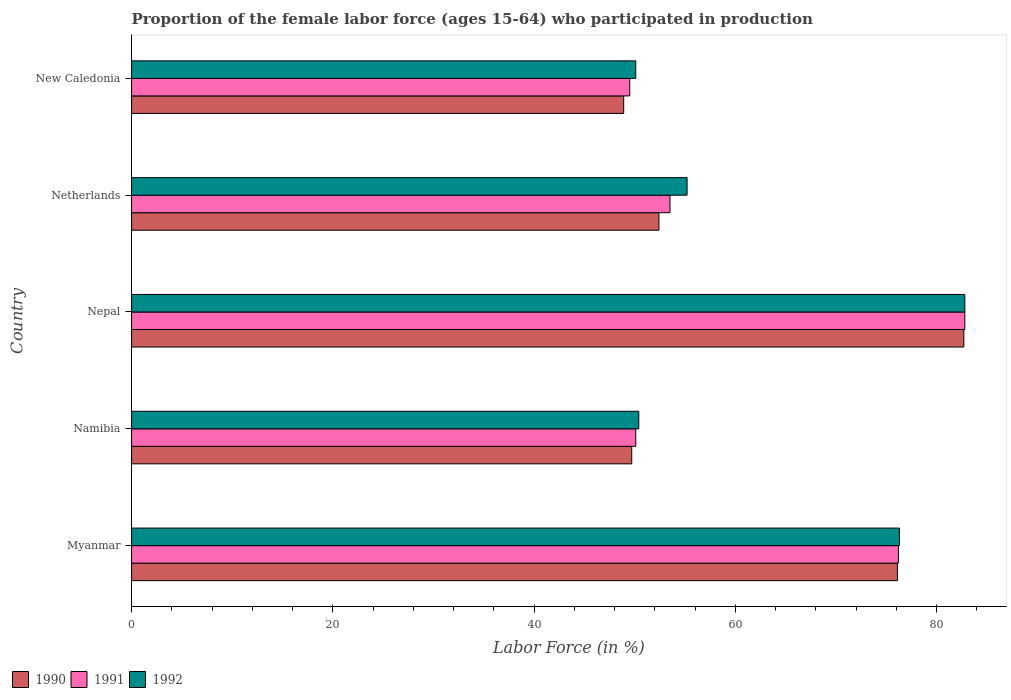Are the number of bars on each tick of the Y-axis equal?
Make the answer very short. Yes. How many bars are there on the 2nd tick from the top?
Your answer should be compact. 3. How many bars are there on the 2nd tick from the bottom?
Keep it short and to the point. 3. In how many cases, is the number of bars for a given country not equal to the number of legend labels?
Provide a short and direct response. 0. What is the proportion of the female labor force who participated in production in 1991 in Myanmar?
Ensure brevity in your answer.  76.2. Across all countries, what is the maximum proportion of the female labor force who participated in production in 1990?
Offer a very short reply. 82.7. Across all countries, what is the minimum proportion of the female labor force who participated in production in 1991?
Your answer should be very brief. 49.5. In which country was the proportion of the female labor force who participated in production in 1992 maximum?
Offer a terse response. Nepal. In which country was the proportion of the female labor force who participated in production in 1991 minimum?
Keep it short and to the point. New Caledonia. What is the total proportion of the female labor force who participated in production in 1992 in the graph?
Provide a succinct answer. 314.8. What is the difference between the proportion of the female labor force who participated in production in 1990 in Nepal and that in New Caledonia?
Your response must be concise. 33.8. What is the difference between the proportion of the female labor force who participated in production in 1990 in Netherlands and the proportion of the female labor force who participated in production in 1991 in Myanmar?
Your answer should be compact. -23.8. What is the average proportion of the female labor force who participated in production in 1990 per country?
Your answer should be very brief. 61.96. What is the difference between the proportion of the female labor force who participated in production in 1990 and proportion of the female labor force who participated in production in 1992 in New Caledonia?
Your answer should be very brief. -1.2. In how many countries, is the proportion of the female labor force who participated in production in 1990 greater than 24 %?
Offer a terse response. 5. What is the ratio of the proportion of the female labor force who participated in production in 1991 in Netherlands to that in New Caledonia?
Keep it short and to the point. 1.08. Is the difference between the proportion of the female labor force who participated in production in 1990 in Netherlands and New Caledonia greater than the difference between the proportion of the female labor force who participated in production in 1992 in Netherlands and New Caledonia?
Your response must be concise. No. What is the difference between the highest and the second highest proportion of the female labor force who participated in production in 1992?
Offer a very short reply. 6.5. What is the difference between the highest and the lowest proportion of the female labor force who participated in production in 1992?
Make the answer very short. 32.7. What does the 1st bar from the top in New Caledonia represents?
Keep it short and to the point. 1992. What does the 3rd bar from the bottom in Nepal represents?
Offer a terse response. 1992. Is it the case that in every country, the sum of the proportion of the female labor force who participated in production in 1992 and proportion of the female labor force who participated in production in 1990 is greater than the proportion of the female labor force who participated in production in 1991?
Your answer should be very brief. Yes. How many bars are there?
Provide a succinct answer. 15. How many countries are there in the graph?
Offer a very short reply. 5. What is the difference between two consecutive major ticks on the X-axis?
Give a very brief answer. 20. Does the graph contain any zero values?
Give a very brief answer. No. Does the graph contain grids?
Provide a short and direct response. No. How many legend labels are there?
Provide a succinct answer. 3. What is the title of the graph?
Provide a short and direct response. Proportion of the female labor force (ages 15-64) who participated in production. Does "2011" appear as one of the legend labels in the graph?
Offer a terse response. No. What is the label or title of the X-axis?
Your answer should be very brief. Labor Force (in %). What is the Labor Force (in %) of 1990 in Myanmar?
Make the answer very short. 76.1. What is the Labor Force (in %) of 1991 in Myanmar?
Make the answer very short. 76.2. What is the Labor Force (in %) of 1992 in Myanmar?
Offer a terse response. 76.3. What is the Labor Force (in %) in 1990 in Namibia?
Keep it short and to the point. 49.7. What is the Labor Force (in %) of 1991 in Namibia?
Offer a very short reply. 50.1. What is the Labor Force (in %) of 1992 in Namibia?
Keep it short and to the point. 50.4. What is the Labor Force (in %) of 1990 in Nepal?
Make the answer very short. 82.7. What is the Labor Force (in %) in 1991 in Nepal?
Offer a very short reply. 82.8. What is the Labor Force (in %) in 1992 in Nepal?
Your response must be concise. 82.8. What is the Labor Force (in %) in 1990 in Netherlands?
Offer a terse response. 52.4. What is the Labor Force (in %) of 1991 in Netherlands?
Offer a terse response. 53.5. What is the Labor Force (in %) of 1992 in Netherlands?
Your answer should be compact. 55.2. What is the Labor Force (in %) of 1990 in New Caledonia?
Give a very brief answer. 48.9. What is the Labor Force (in %) in 1991 in New Caledonia?
Your response must be concise. 49.5. What is the Labor Force (in %) in 1992 in New Caledonia?
Your answer should be very brief. 50.1. Across all countries, what is the maximum Labor Force (in %) in 1990?
Ensure brevity in your answer.  82.7. Across all countries, what is the maximum Labor Force (in %) of 1991?
Your answer should be very brief. 82.8. Across all countries, what is the maximum Labor Force (in %) in 1992?
Offer a terse response. 82.8. Across all countries, what is the minimum Labor Force (in %) of 1990?
Offer a very short reply. 48.9. Across all countries, what is the minimum Labor Force (in %) of 1991?
Your answer should be very brief. 49.5. Across all countries, what is the minimum Labor Force (in %) of 1992?
Offer a very short reply. 50.1. What is the total Labor Force (in %) of 1990 in the graph?
Ensure brevity in your answer.  309.8. What is the total Labor Force (in %) in 1991 in the graph?
Provide a succinct answer. 312.1. What is the total Labor Force (in %) of 1992 in the graph?
Keep it short and to the point. 314.8. What is the difference between the Labor Force (in %) of 1990 in Myanmar and that in Namibia?
Offer a very short reply. 26.4. What is the difference between the Labor Force (in %) in 1991 in Myanmar and that in Namibia?
Ensure brevity in your answer.  26.1. What is the difference between the Labor Force (in %) of 1992 in Myanmar and that in Namibia?
Your answer should be very brief. 25.9. What is the difference between the Labor Force (in %) in 1990 in Myanmar and that in Nepal?
Give a very brief answer. -6.6. What is the difference between the Labor Force (in %) of 1990 in Myanmar and that in Netherlands?
Your response must be concise. 23.7. What is the difference between the Labor Force (in %) of 1991 in Myanmar and that in Netherlands?
Make the answer very short. 22.7. What is the difference between the Labor Force (in %) of 1992 in Myanmar and that in Netherlands?
Your response must be concise. 21.1. What is the difference between the Labor Force (in %) in 1990 in Myanmar and that in New Caledonia?
Your answer should be very brief. 27.2. What is the difference between the Labor Force (in %) of 1991 in Myanmar and that in New Caledonia?
Provide a short and direct response. 26.7. What is the difference between the Labor Force (in %) in 1992 in Myanmar and that in New Caledonia?
Your answer should be compact. 26.2. What is the difference between the Labor Force (in %) of 1990 in Namibia and that in Nepal?
Offer a very short reply. -33. What is the difference between the Labor Force (in %) in 1991 in Namibia and that in Nepal?
Ensure brevity in your answer.  -32.7. What is the difference between the Labor Force (in %) in 1992 in Namibia and that in Nepal?
Your response must be concise. -32.4. What is the difference between the Labor Force (in %) in 1991 in Namibia and that in Netherlands?
Your response must be concise. -3.4. What is the difference between the Labor Force (in %) in 1992 in Namibia and that in Netherlands?
Offer a very short reply. -4.8. What is the difference between the Labor Force (in %) of 1990 in Namibia and that in New Caledonia?
Provide a short and direct response. 0.8. What is the difference between the Labor Force (in %) of 1991 in Namibia and that in New Caledonia?
Your answer should be compact. 0.6. What is the difference between the Labor Force (in %) in 1992 in Namibia and that in New Caledonia?
Give a very brief answer. 0.3. What is the difference between the Labor Force (in %) in 1990 in Nepal and that in Netherlands?
Your answer should be very brief. 30.3. What is the difference between the Labor Force (in %) in 1991 in Nepal and that in Netherlands?
Give a very brief answer. 29.3. What is the difference between the Labor Force (in %) in 1992 in Nepal and that in Netherlands?
Offer a very short reply. 27.6. What is the difference between the Labor Force (in %) of 1990 in Nepal and that in New Caledonia?
Make the answer very short. 33.8. What is the difference between the Labor Force (in %) in 1991 in Nepal and that in New Caledonia?
Provide a succinct answer. 33.3. What is the difference between the Labor Force (in %) in 1992 in Nepal and that in New Caledonia?
Ensure brevity in your answer.  32.7. What is the difference between the Labor Force (in %) in 1991 in Netherlands and that in New Caledonia?
Your answer should be very brief. 4. What is the difference between the Labor Force (in %) of 1990 in Myanmar and the Labor Force (in %) of 1992 in Namibia?
Your response must be concise. 25.7. What is the difference between the Labor Force (in %) in 1991 in Myanmar and the Labor Force (in %) in 1992 in Namibia?
Your answer should be compact. 25.8. What is the difference between the Labor Force (in %) in 1991 in Myanmar and the Labor Force (in %) in 1992 in Nepal?
Your answer should be very brief. -6.6. What is the difference between the Labor Force (in %) of 1990 in Myanmar and the Labor Force (in %) of 1991 in Netherlands?
Ensure brevity in your answer.  22.6. What is the difference between the Labor Force (in %) of 1990 in Myanmar and the Labor Force (in %) of 1992 in Netherlands?
Your answer should be very brief. 20.9. What is the difference between the Labor Force (in %) of 1991 in Myanmar and the Labor Force (in %) of 1992 in Netherlands?
Your response must be concise. 21. What is the difference between the Labor Force (in %) of 1990 in Myanmar and the Labor Force (in %) of 1991 in New Caledonia?
Offer a very short reply. 26.6. What is the difference between the Labor Force (in %) of 1990 in Myanmar and the Labor Force (in %) of 1992 in New Caledonia?
Ensure brevity in your answer.  26. What is the difference between the Labor Force (in %) in 1991 in Myanmar and the Labor Force (in %) in 1992 in New Caledonia?
Make the answer very short. 26.1. What is the difference between the Labor Force (in %) of 1990 in Namibia and the Labor Force (in %) of 1991 in Nepal?
Keep it short and to the point. -33.1. What is the difference between the Labor Force (in %) in 1990 in Namibia and the Labor Force (in %) in 1992 in Nepal?
Provide a short and direct response. -33.1. What is the difference between the Labor Force (in %) in 1991 in Namibia and the Labor Force (in %) in 1992 in Nepal?
Make the answer very short. -32.7. What is the difference between the Labor Force (in %) of 1990 in Namibia and the Labor Force (in %) of 1991 in Netherlands?
Your answer should be compact. -3.8. What is the difference between the Labor Force (in %) in 1990 in Namibia and the Labor Force (in %) in 1992 in Netherlands?
Ensure brevity in your answer.  -5.5. What is the difference between the Labor Force (in %) in 1991 in Namibia and the Labor Force (in %) in 1992 in New Caledonia?
Provide a short and direct response. 0. What is the difference between the Labor Force (in %) of 1990 in Nepal and the Labor Force (in %) of 1991 in Netherlands?
Your answer should be compact. 29.2. What is the difference between the Labor Force (in %) of 1991 in Nepal and the Labor Force (in %) of 1992 in Netherlands?
Your answer should be very brief. 27.6. What is the difference between the Labor Force (in %) of 1990 in Nepal and the Labor Force (in %) of 1991 in New Caledonia?
Make the answer very short. 33.2. What is the difference between the Labor Force (in %) of 1990 in Nepal and the Labor Force (in %) of 1992 in New Caledonia?
Your response must be concise. 32.6. What is the difference between the Labor Force (in %) in 1991 in Nepal and the Labor Force (in %) in 1992 in New Caledonia?
Keep it short and to the point. 32.7. What is the difference between the Labor Force (in %) of 1990 in Netherlands and the Labor Force (in %) of 1991 in New Caledonia?
Your answer should be compact. 2.9. What is the average Labor Force (in %) of 1990 per country?
Give a very brief answer. 61.96. What is the average Labor Force (in %) of 1991 per country?
Offer a very short reply. 62.42. What is the average Labor Force (in %) in 1992 per country?
Give a very brief answer. 62.96. What is the difference between the Labor Force (in %) of 1990 and Labor Force (in %) of 1992 in Namibia?
Provide a succinct answer. -0.7. What is the difference between the Labor Force (in %) in 1990 and Labor Force (in %) in 1991 in Nepal?
Provide a short and direct response. -0.1. What is the difference between the Labor Force (in %) of 1990 and Labor Force (in %) of 1992 in Nepal?
Keep it short and to the point. -0.1. What is the difference between the Labor Force (in %) in 1990 and Labor Force (in %) in 1991 in Netherlands?
Your answer should be very brief. -1.1. What is the ratio of the Labor Force (in %) in 1990 in Myanmar to that in Namibia?
Offer a very short reply. 1.53. What is the ratio of the Labor Force (in %) of 1991 in Myanmar to that in Namibia?
Make the answer very short. 1.52. What is the ratio of the Labor Force (in %) of 1992 in Myanmar to that in Namibia?
Keep it short and to the point. 1.51. What is the ratio of the Labor Force (in %) of 1990 in Myanmar to that in Nepal?
Ensure brevity in your answer.  0.92. What is the ratio of the Labor Force (in %) of 1991 in Myanmar to that in Nepal?
Keep it short and to the point. 0.92. What is the ratio of the Labor Force (in %) of 1992 in Myanmar to that in Nepal?
Provide a succinct answer. 0.92. What is the ratio of the Labor Force (in %) in 1990 in Myanmar to that in Netherlands?
Your response must be concise. 1.45. What is the ratio of the Labor Force (in %) in 1991 in Myanmar to that in Netherlands?
Ensure brevity in your answer.  1.42. What is the ratio of the Labor Force (in %) in 1992 in Myanmar to that in Netherlands?
Ensure brevity in your answer.  1.38. What is the ratio of the Labor Force (in %) in 1990 in Myanmar to that in New Caledonia?
Ensure brevity in your answer.  1.56. What is the ratio of the Labor Force (in %) of 1991 in Myanmar to that in New Caledonia?
Your answer should be very brief. 1.54. What is the ratio of the Labor Force (in %) in 1992 in Myanmar to that in New Caledonia?
Provide a succinct answer. 1.52. What is the ratio of the Labor Force (in %) of 1990 in Namibia to that in Nepal?
Offer a very short reply. 0.6. What is the ratio of the Labor Force (in %) of 1991 in Namibia to that in Nepal?
Make the answer very short. 0.61. What is the ratio of the Labor Force (in %) in 1992 in Namibia to that in Nepal?
Give a very brief answer. 0.61. What is the ratio of the Labor Force (in %) of 1990 in Namibia to that in Netherlands?
Give a very brief answer. 0.95. What is the ratio of the Labor Force (in %) of 1991 in Namibia to that in Netherlands?
Offer a very short reply. 0.94. What is the ratio of the Labor Force (in %) in 1990 in Namibia to that in New Caledonia?
Your answer should be compact. 1.02. What is the ratio of the Labor Force (in %) of 1991 in Namibia to that in New Caledonia?
Keep it short and to the point. 1.01. What is the ratio of the Labor Force (in %) of 1990 in Nepal to that in Netherlands?
Give a very brief answer. 1.58. What is the ratio of the Labor Force (in %) in 1991 in Nepal to that in Netherlands?
Keep it short and to the point. 1.55. What is the ratio of the Labor Force (in %) in 1992 in Nepal to that in Netherlands?
Keep it short and to the point. 1.5. What is the ratio of the Labor Force (in %) of 1990 in Nepal to that in New Caledonia?
Make the answer very short. 1.69. What is the ratio of the Labor Force (in %) in 1991 in Nepal to that in New Caledonia?
Offer a very short reply. 1.67. What is the ratio of the Labor Force (in %) of 1992 in Nepal to that in New Caledonia?
Provide a short and direct response. 1.65. What is the ratio of the Labor Force (in %) in 1990 in Netherlands to that in New Caledonia?
Give a very brief answer. 1.07. What is the ratio of the Labor Force (in %) of 1991 in Netherlands to that in New Caledonia?
Make the answer very short. 1.08. What is the ratio of the Labor Force (in %) of 1992 in Netherlands to that in New Caledonia?
Ensure brevity in your answer.  1.1. What is the difference between the highest and the second highest Labor Force (in %) in 1990?
Offer a very short reply. 6.6. What is the difference between the highest and the second highest Labor Force (in %) in 1992?
Provide a short and direct response. 6.5. What is the difference between the highest and the lowest Labor Force (in %) in 1990?
Your answer should be compact. 33.8. What is the difference between the highest and the lowest Labor Force (in %) in 1991?
Give a very brief answer. 33.3. What is the difference between the highest and the lowest Labor Force (in %) of 1992?
Offer a very short reply. 32.7. 